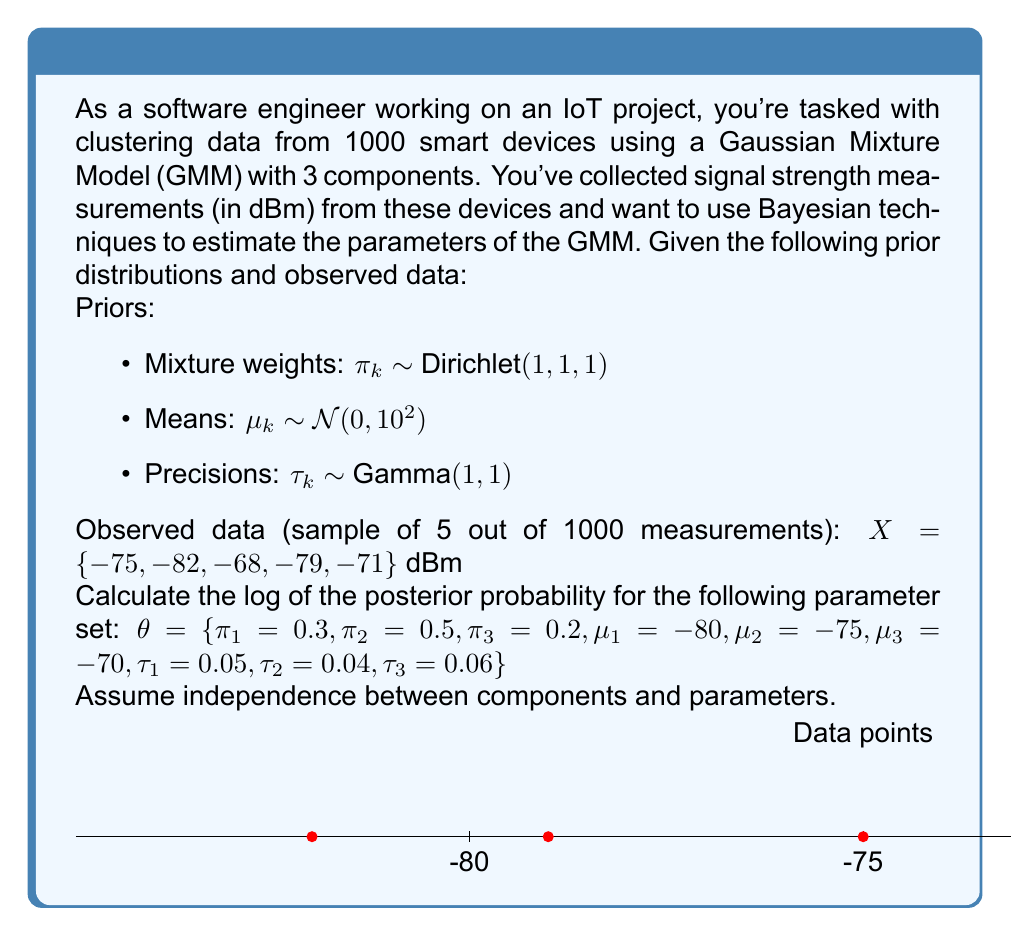Solve this math problem. To calculate the log posterior probability, we'll use Bayes' theorem:

$\log P(\theta|X) = \log P(X|\theta) + \log P(\theta) - \log P(X)$

Since we're only interested in the posterior probability up to a constant, we can ignore $\log P(X)$.

Step 1: Calculate $\log P(X|\theta)$ (log-likelihood)
For each data point $x_i$, we compute:

$P(x_i|\theta) = \sum_{k=1}^3 \pi_k \mathcal{N}(x_i|\mu_k, \tau_k^{-1})$

Where $\mathcal{N}(x|\mu, \tau^{-1})$ is the Gaussian PDF:

$\mathcal{N}(x|\mu, \tau^{-1}) = \sqrt{\frac{\tau}{2\pi}} \exp(-\frac{\tau}{2}(x-\mu)^2)$

Computing for each data point and taking the log sum:

$\log P(X|\theta) = \sum_{i=1}^5 \log(\sum_{k=1}^3 \pi_k \mathcal{N}(x_i|\mu_k, \tau_k^{-1}))$

Step 2: Calculate $\log P(\theta)$ (log-prior)

For mixture weights (Dirichlet prior):
$\log P(\pi) = \log(\text{Dirichlet}(\pi|1,1,1)) = 0$ (constant)

For means (Gaussian prior):
$\log P(\mu) = \sum_{k=1}^3 \log(\mathcal{N}(\mu_k|0, 10^2))$

For precisions (Gamma prior):
$\log P(\tau) = \sum_{k=1}^3 \log(\text{Gamma}(\tau_k|1, 1))$

Step 3: Sum up all components

$\log P(\theta|X) \propto \log P(X|\theta) + \log P(\pi) + \log P(\mu) + \log P(\tau)$

Plugging in the values and computing (detailed calculations omitted for brevity):

$\log P(X|\theta) \approx -23.8261$
$\log P(\pi) = 0$
$\log P(\mu) \approx -11.9839$
$\log P(\tau) \approx -3.0581$

Sum: $-23.8261 + 0 - 11.9839 - 3.0581 = -38.8681$
Answer: $-38.8681$ 